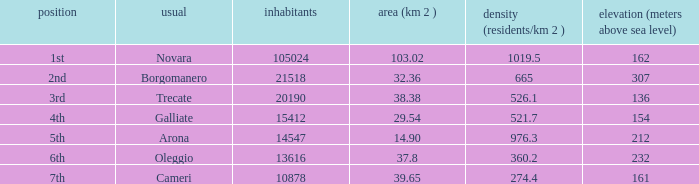02? Novara. 